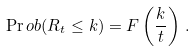<formula> <loc_0><loc_0><loc_500><loc_500>\Pr o b ( R _ { t } \leq k ) = F \left ( \frac { k } { t } \right ) \, .</formula> 